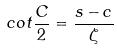<formula> <loc_0><loc_0><loc_500><loc_500>c o t \frac { C } { 2 } = \frac { s - c } { \zeta }</formula> 